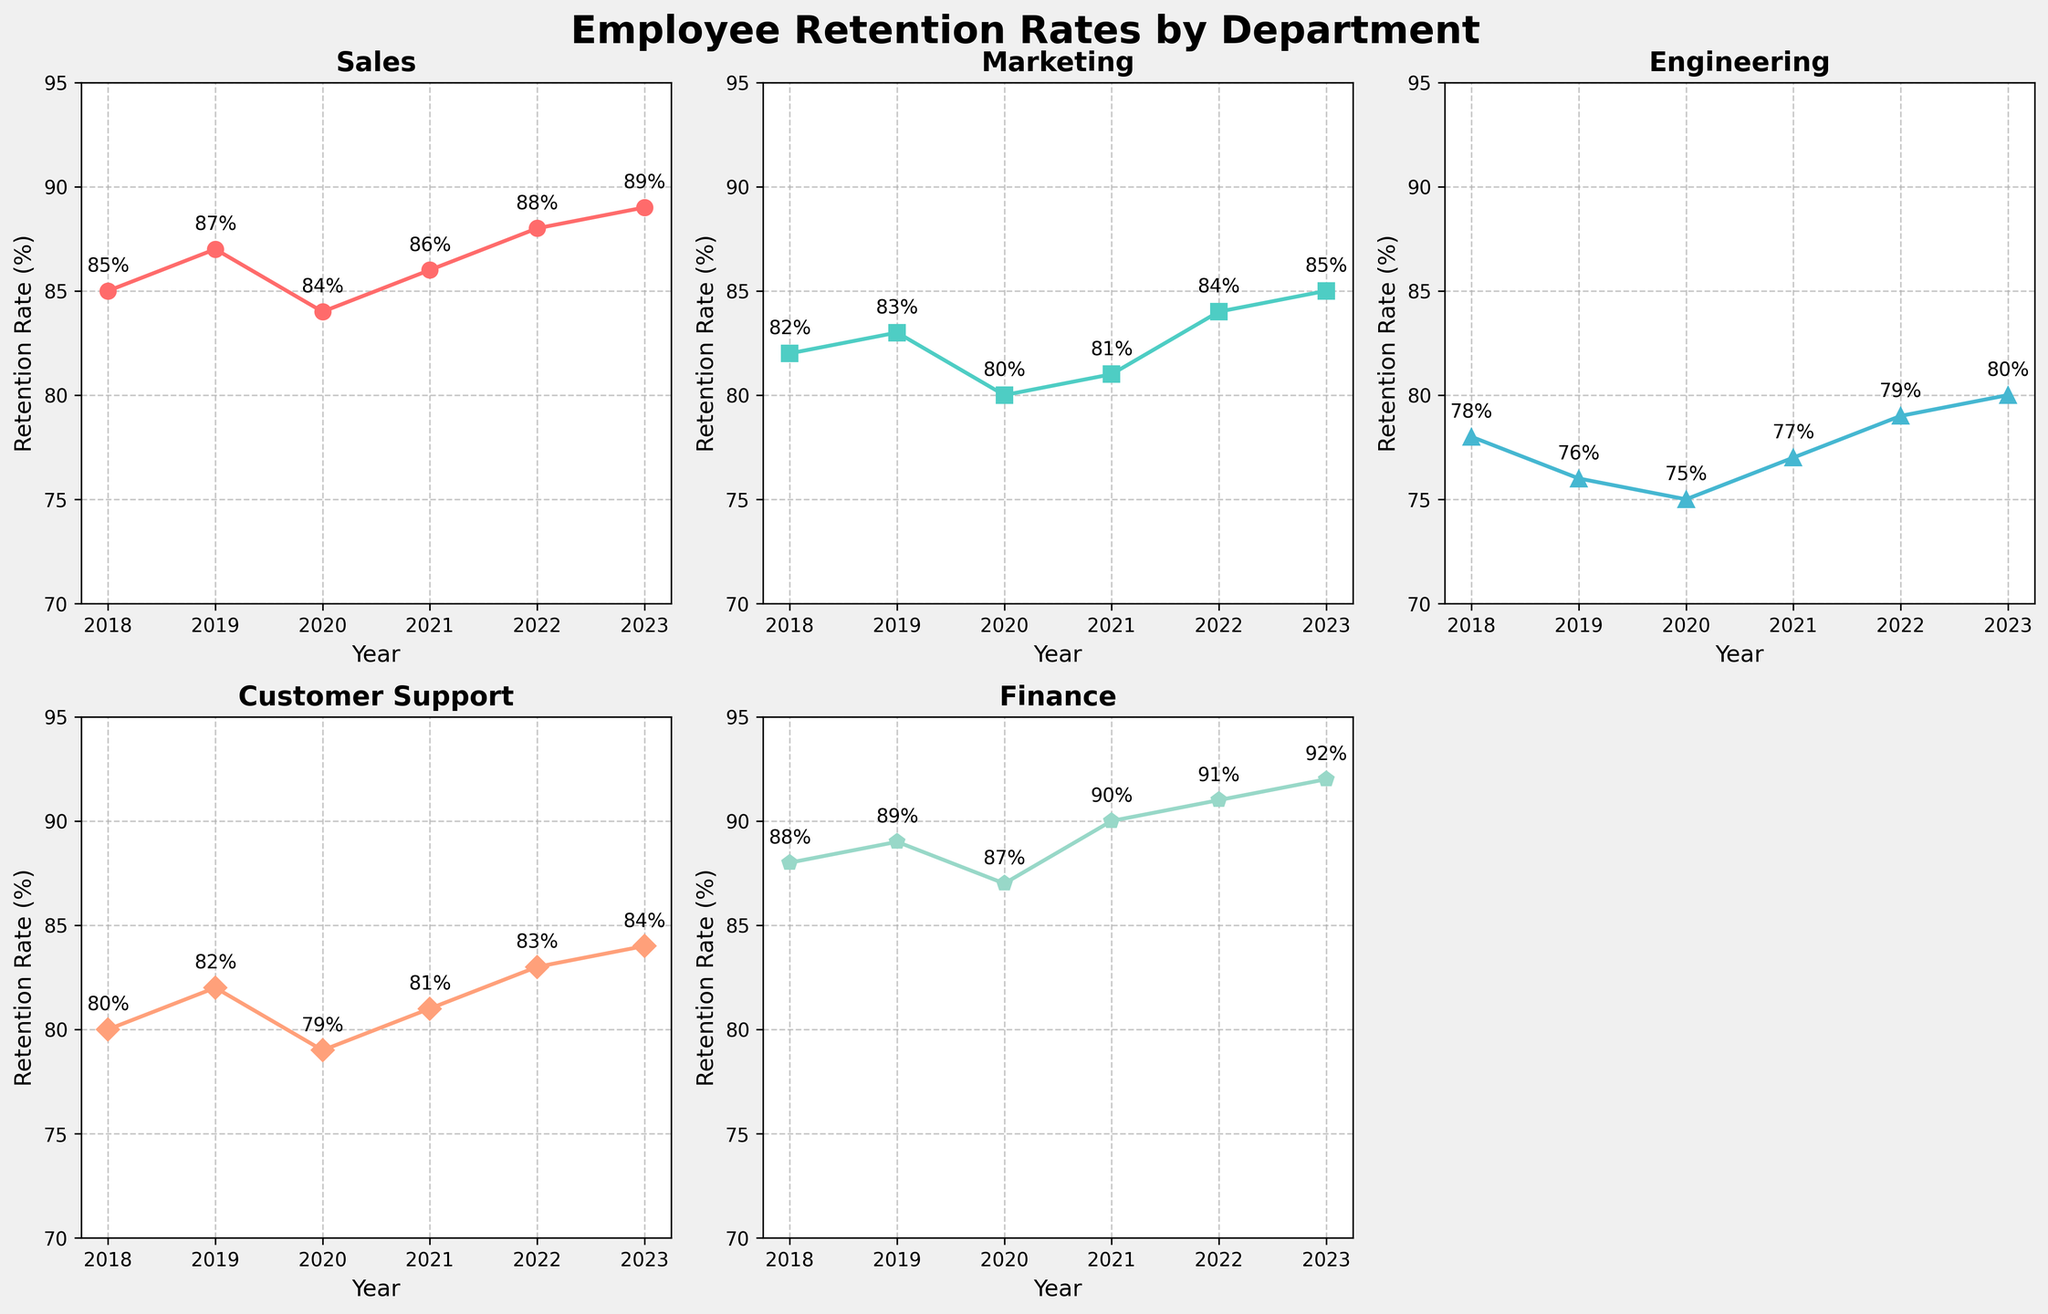What's the title of the figure? The title is located at the top center of the figure and is written in bold.
Answer: Employee Retention Rates by Department Which department had the highest retention rate in 2023? By looking at the 2023 data points, the department with the highest value is the one near the top. The Finance department shows the highest retention rate.
Answer: Finance What was the average retention rate for the Marketing department over the years? Add the retention rates for Marketing for each year and divide by the number of years. The rates are 82, 83, 80, 81, 84, and 85. Their sum is 495. Divide 495 by 6 (the number of years) to get the average.
Answer: 82.5 Which department showed the most fluctuation in retention rates over the years? The most fluctuation can be identified by looking for the line with the most significant up and down movements. The Engineering department's line has noticeable fluctuations, especially between 2018 and 2020.
Answer: Engineering Compare the retention rates between Sales and Engineering in 2020. Which was higher and by how much? Locate the retention rates for both departments in 2020. The Sales retention rate was 84%, and the Engineering retention rate was 75%. Subtract the retention rate of Engineering from Sales.
Answer: Sales by 9% Which department showed a consistent year-on-year increase in retention rates from 2018 to 2023? Check the lines to see which one moves upward each year without any decreases. The Finance department shows a consistent increase.
Answer: Finance How many departments are represented in the figure? Count the number of subplots with titles, noting that the bottom right subplot is empty.
Answer: 5 What is the retention rate trend for Customer Support over the years? Trace the line for Customer Support from 2018 to 2023. Starting at 80% in 2018, it goes up to 82% in 2019, drops slightly in 2020, and then gradually increases again to 84% by 2023.
Answer: Increasing Which department had the lowest retention rate in 2019, and what was the value? Locate the retention values across departments for 2019, finding the lowest one. Engineering has the lowest retention rate of 76%.
Answer: Engineering, 76% 